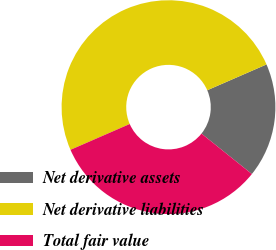<chart> <loc_0><loc_0><loc_500><loc_500><pie_chart><fcel>Net derivative assets<fcel>Net derivative liabilities<fcel>Total fair value<nl><fcel>17.3%<fcel>50.0%<fcel>32.7%<nl></chart> 